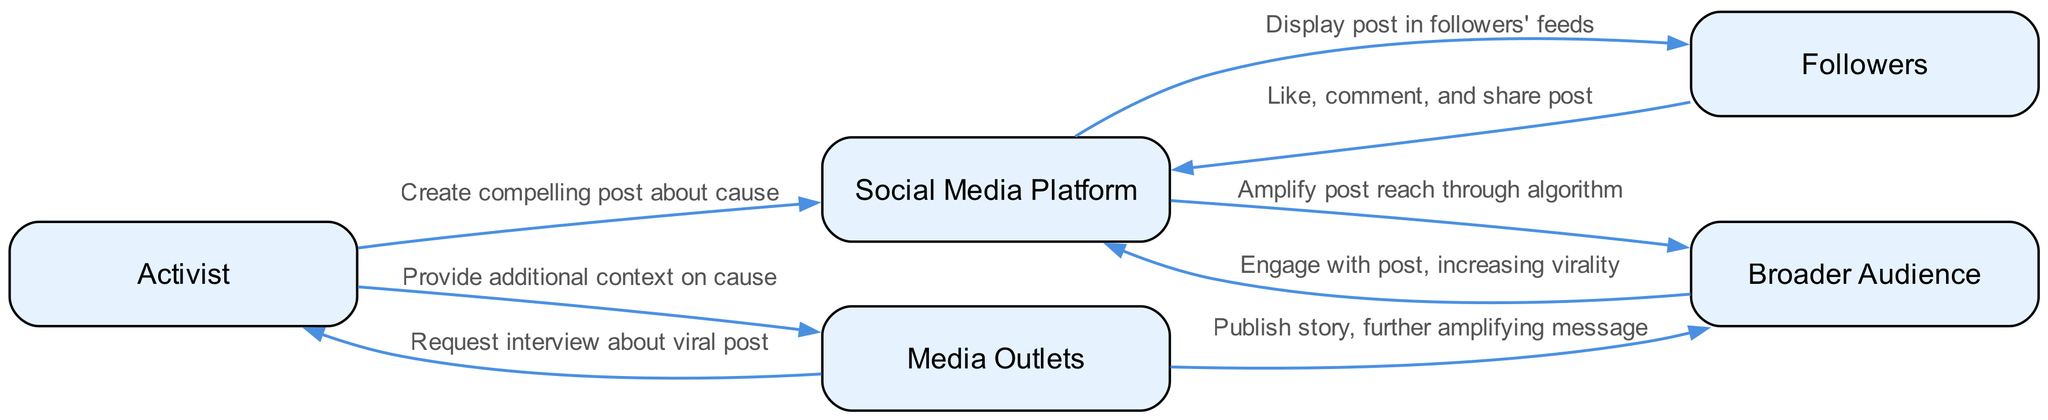What is the total number of actors in the diagram? The diagram lists five actors: Activist, Social Media Platform, Followers, Broader Audience, and Media Outlets. By counting each one, we find there are five distinct entities in the diagram.
Answer: five What action does the Followers take towards the Social Media Platform? The Followers perform the action of liking, commenting, and sharing the post towards the Social Media Platform, as stated in the sequence connecting these two nodes.
Answer: Like, comment, and share post Which actor requests an interview from the Activist? According to the diagram, Media Outlets are the ones that reach out to the Activist for an interview regarding the viral post, making them the key actor in this action.
Answer: Media Outlets What is the relationship between Broader Audience and Social Media Platform? The sequence shows that the Broader Audience engages with the post, which increases its virality. This indicates a feedback loop where engagement leads to further visibility provided by the Social Media Platform.
Answer: Engage with post, increasing virality How many distinct actions take place between the Activist and Media Outlets? There are two distinct actions between these nodes: first, the Media Outlets request an interview from the Activist, and second, the Activist provides additional context on the cause. Counting these actions gives a total of two.
Answer: two What happens after the Social Media Platform displays the post to Followers? After the post is displayed in the followers' feeds, they interact by liking, commenting, and sharing it. This creates a chain reaction leading to broader engagement and visibility.
Answer: Like, comment, and share post Which actor amplifies the post's reach through algorithms? The Social Media Platform is responsible for amplifying the post's reach as indicated in the sequence that describes its function using algorithms to enhance visibility among a broader audience.
Answer: Social Media Platform What is the final action taken by Media Outlets? The final action taken by Media Outlets is to publish a story that further amplifies the message of the viral post to a broader audience. This is the closure of the engagement loop.
Answer: Publish story, further amplifying message 